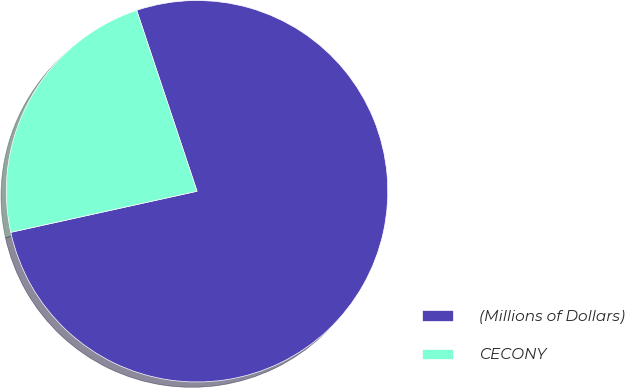Convert chart. <chart><loc_0><loc_0><loc_500><loc_500><pie_chart><fcel>(Millions of Dollars)<fcel>CECONY<nl><fcel>76.67%<fcel>23.33%<nl></chart> 